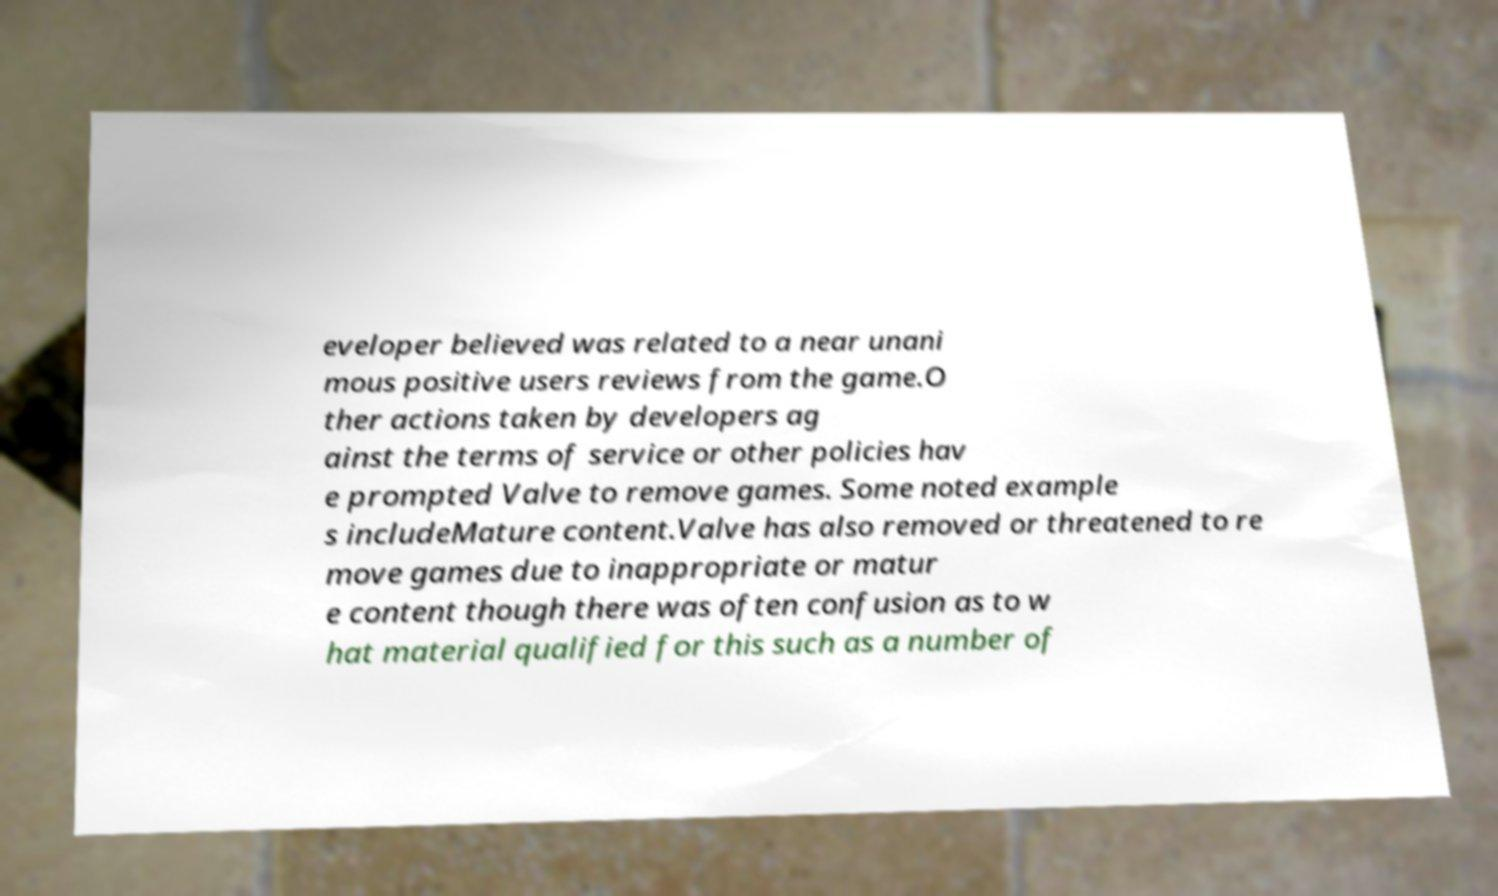For documentation purposes, I need the text within this image transcribed. Could you provide that? eveloper believed was related to a near unani mous positive users reviews from the game.O ther actions taken by developers ag ainst the terms of service or other policies hav e prompted Valve to remove games. Some noted example s includeMature content.Valve has also removed or threatened to re move games due to inappropriate or matur e content though there was often confusion as to w hat material qualified for this such as a number of 